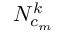Convert formula to latex. <formula><loc_0><loc_0><loc_500><loc_500>N _ { c _ { m } } ^ { k }</formula> 